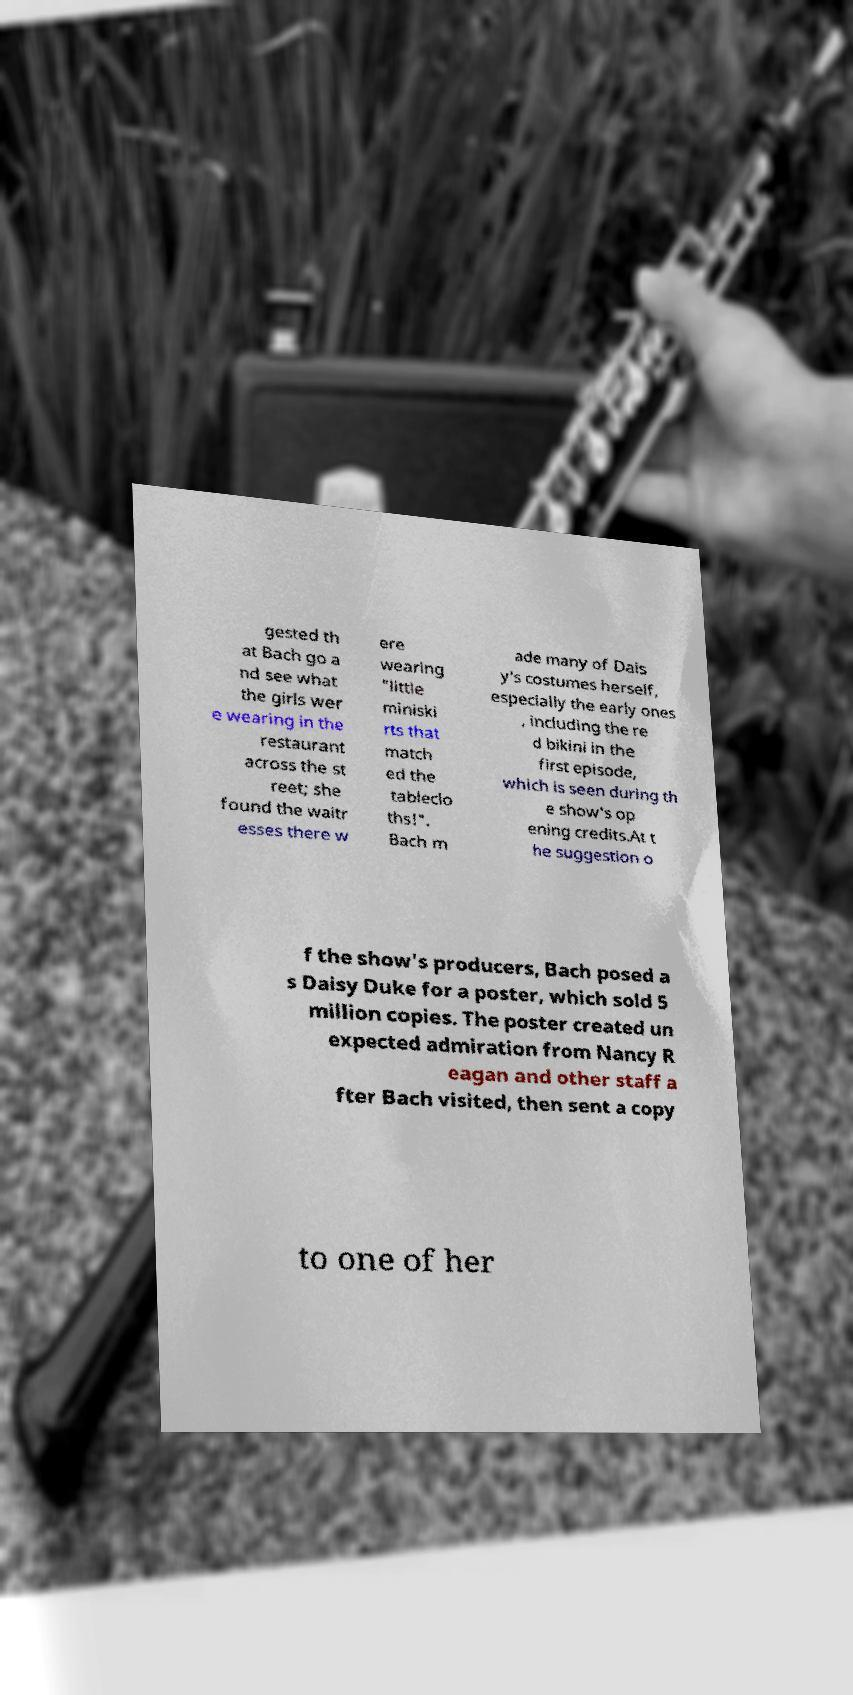Can you read and provide the text displayed in the image?This photo seems to have some interesting text. Can you extract and type it out for me? gested th at Bach go a nd see what the girls wer e wearing in the restaurant across the st reet; she found the waitr esses there w ere wearing "little miniski rts that match ed the tableclo ths!". Bach m ade many of Dais y's costumes herself, especially the early ones , including the re d bikini in the first episode, which is seen during th e show's op ening credits.At t he suggestion o f the show's producers, Bach posed a s Daisy Duke for a poster, which sold 5 million copies. The poster created un expected admiration from Nancy R eagan and other staff a fter Bach visited, then sent a copy to one of her 